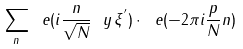Convert formula to latex. <formula><loc_0><loc_0><loc_500><loc_500>\sum _ { n } \ e ( i \frac { n } { \sqrt { N } } \ y \, \xi ^ { ^ { \prime } } ) \cdot \ e ( - 2 \pi i \frac { p } { N } n )</formula> 